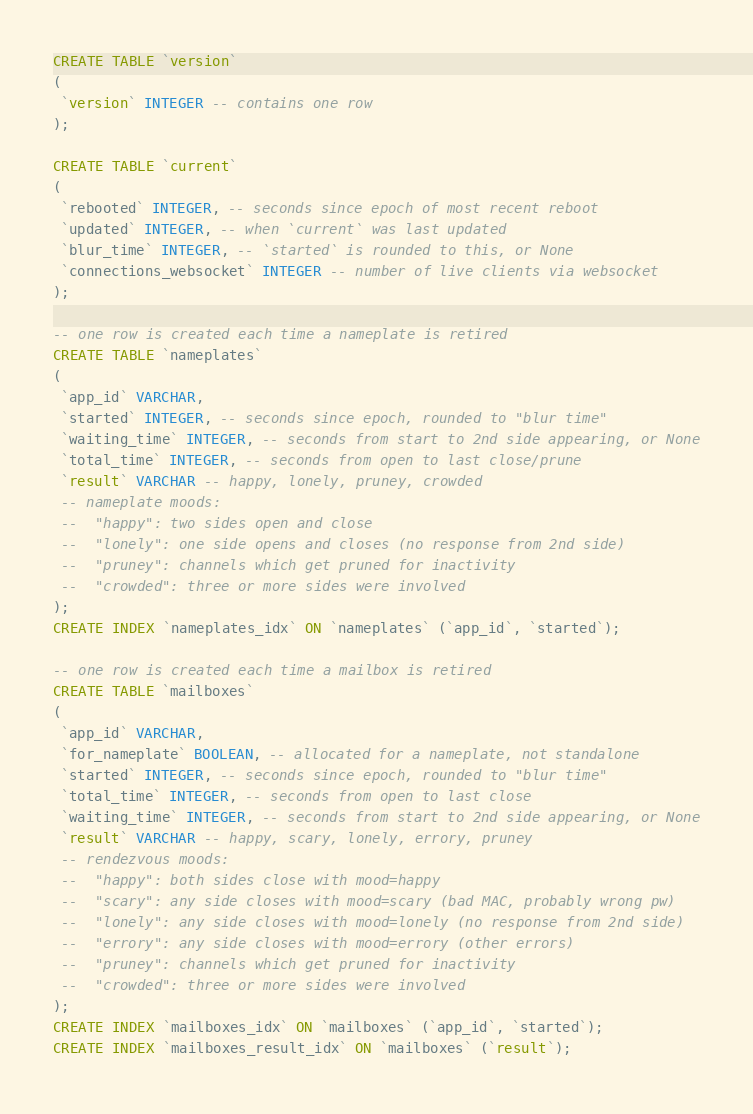<code> <loc_0><loc_0><loc_500><loc_500><_SQL_>CREATE TABLE `version`
(
 `version` INTEGER -- contains one row
);

CREATE TABLE `current`
(
 `rebooted` INTEGER, -- seconds since epoch of most recent reboot
 `updated` INTEGER, -- when `current` was last updated
 `blur_time` INTEGER, -- `started` is rounded to this, or None
 `connections_websocket` INTEGER -- number of live clients via websocket
);

-- one row is created each time a nameplate is retired
CREATE TABLE `nameplates`
(
 `app_id` VARCHAR,
 `started` INTEGER, -- seconds since epoch, rounded to "blur time"
 `waiting_time` INTEGER, -- seconds from start to 2nd side appearing, or None
 `total_time` INTEGER, -- seconds from open to last close/prune
 `result` VARCHAR -- happy, lonely, pruney, crowded
 -- nameplate moods:
 --  "happy": two sides open and close
 --  "lonely": one side opens and closes (no response from 2nd side)
 --  "pruney": channels which get pruned for inactivity
 --  "crowded": three or more sides were involved
);
CREATE INDEX `nameplates_idx` ON `nameplates` (`app_id`, `started`);

-- one row is created each time a mailbox is retired
CREATE TABLE `mailboxes`
(
 `app_id` VARCHAR,
 `for_nameplate` BOOLEAN, -- allocated for a nameplate, not standalone
 `started` INTEGER, -- seconds since epoch, rounded to "blur time"
 `total_time` INTEGER, -- seconds from open to last close
 `waiting_time` INTEGER, -- seconds from start to 2nd side appearing, or None
 `result` VARCHAR -- happy, scary, lonely, errory, pruney
 -- rendezvous moods:
 --  "happy": both sides close with mood=happy
 --  "scary": any side closes with mood=scary (bad MAC, probably wrong pw)
 --  "lonely": any side closes with mood=lonely (no response from 2nd side)
 --  "errory": any side closes with mood=errory (other errors)
 --  "pruney": channels which get pruned for inactivity
 --  "crowded": three or more sides were involved
);
CREATE INDEX `mailboxes_idx` ON `mailboxes` (`app_id`, `started`);
CREATE INDEX `mailboxes_result_idx` ON `mailboxes` (`result`);
</code> 